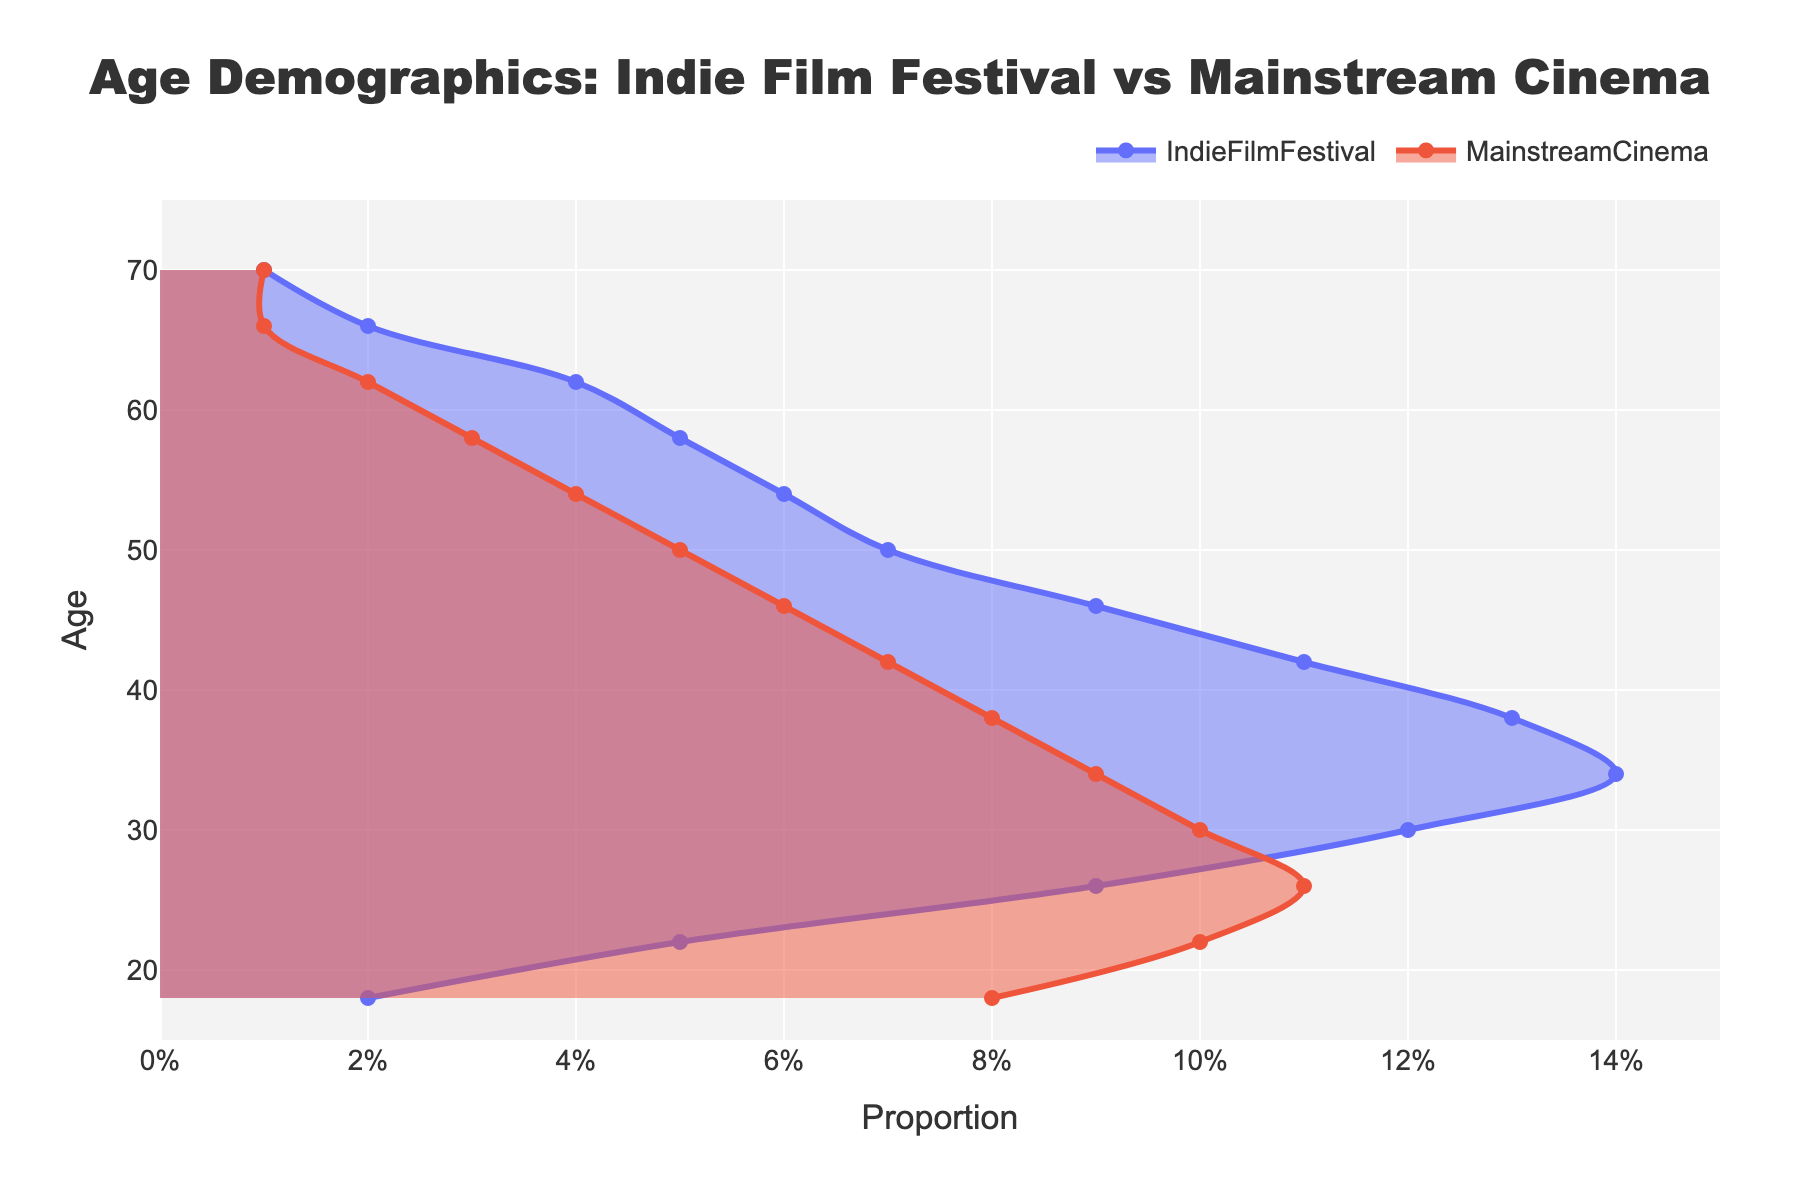What is the title of the plot? Look at the top of the plot where the title is written.
Answer: Age Demographics: Indie Film Festival vs Mainstream Cinema Which age group is most represented at indie film festivals? Look at the density peak for the Indie Film Festival line and identify the age group with the highest proportion.
Answer: 34 How do the demographics of 22-year-old attendees differ between indie film festivals and mainstream cinemas? Compare the heights of the density lines at age 22 for both indie film festivals and mainstream cinemas.
Answer: Indie Film Festival: 0.05, Mainstream Cinema: 0.10 Which age group shows similar proportions for both indie film festivals and mainstream cinemas? Look for the age groups where the density lines for both indie film festivals and mainstream cinemas are at similar heights.
Answer: 66-70 What is the maximum proportion of attendees for mainstream cinemas, and at what age does it occur? Identify the peak of the Mainstream Cinema line and note the approximate value and corresponding age.
Answer: 0.11 at 26 How does the proportion of attendees aged 54 at indie film festivals compare to those at mainstream cinemas? Locate age 54 on the plot and compare the densities of both lines.
Answer: Indie Film Festival: 0.06, Mainstream Cinema: 0.04 Does the proportion of attendees for indie film festivals increase or decrease after age 34? Observe the trend of the Indie Film Festival line after age 34.
Answer: Decrease At what age does the proportion of indie film festival attendees equal 0.09? Identify the age values on the plot where the Indie Film Festival line reaches the height of 0.09.
Answer: 26 and 46 What is the proportion difference between indie film festivals and mainstream cinema attendees at age 38? Find the values for both lines at age 38 and calculate the difference.
Answer: 0.13 - 0.08 = 0.05 Which age group has the lowest representation at mainstream cinemas? Look for the age group where the Mainstream Cinema line has the lowest density.
Answer: 66-70 